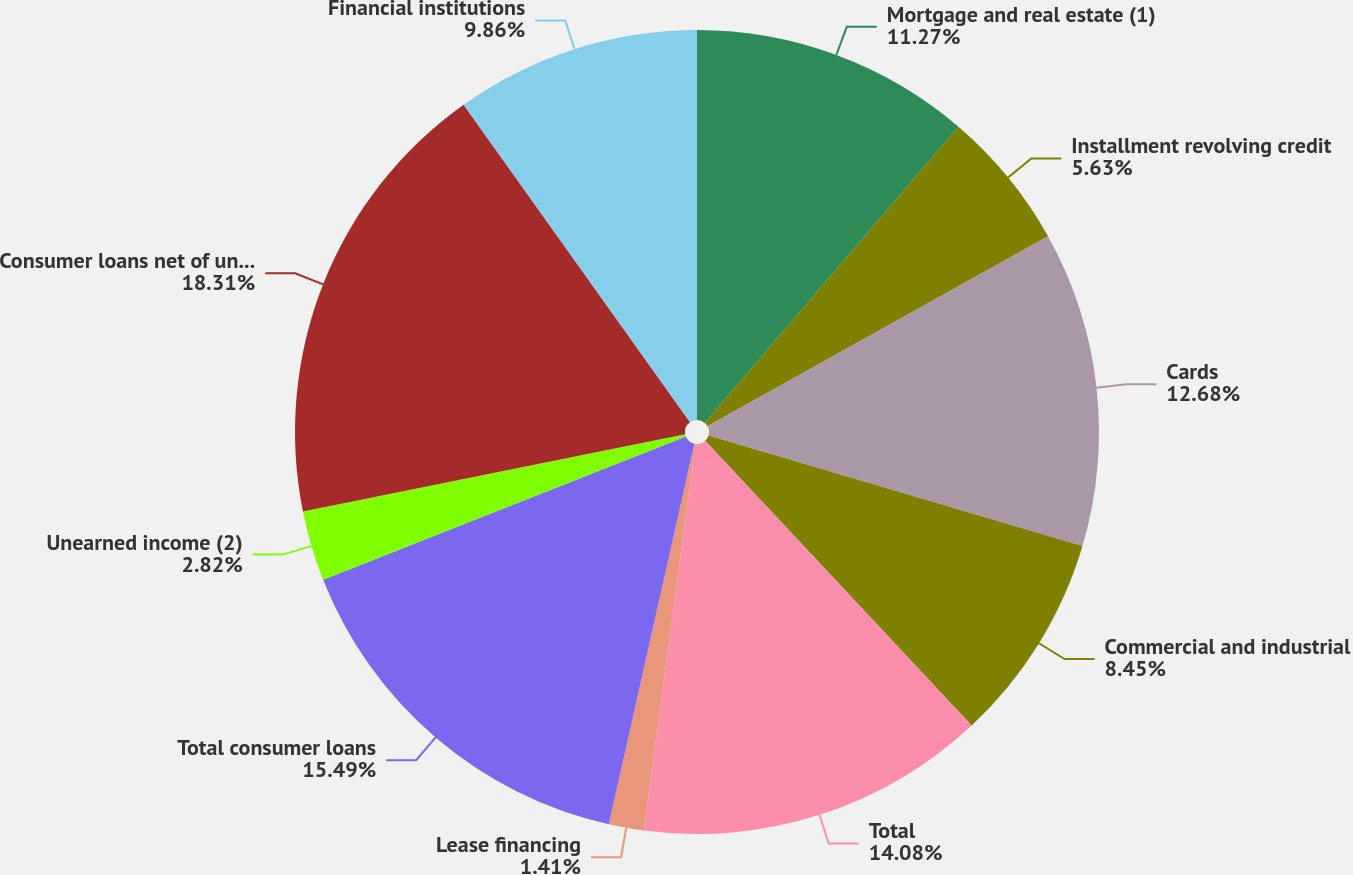<chart> <loc_0><loc_0><loc_500><loc_500><pie_chart><fcel>Mortgage and real estate (1)<fcel>Installment revolving credit<fcel>Cards<fcel>Commercial and industrial<fcel>Total<fcel>Lease financing<fcel>Total consumer loans<fcel>Unearned income (2)<fcel>Consumer loans net of unearned<fcel>Financial institutions<nl><fcel>11.27%<fcel>5.63%<fcel>12.68%<fcel>8.45%<fcel>14.08%<fcel>1.41%<fcel>15.49%<fcel>2.82%<fcel>18.31%<fcel>9.86%<nl></chart> 